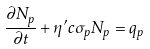<formula> <loc_0><loc_0><loc_500><loc_500>\frac { \partial N _ { p } } { \partial t } + \eta ^ { \prime } c \sigma _ { p } N _ { p } = q _ { p }</formula> 